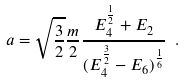<formula> <loc_0><loc_0><loc_500><loc_500>a = \sqrt { \frac { 3 } { 2 } } \frac { m } { 2 } \frac { E _ { 4 } ^ { \frac { 1 } { 2 } } + E _ { 2 } } { ( E _ { 4 } ^ { \frac { 3 } { 2 } } - E _ { 6 } ) ^ { \frac { 1 } { 6 } } } \ .</formula> 